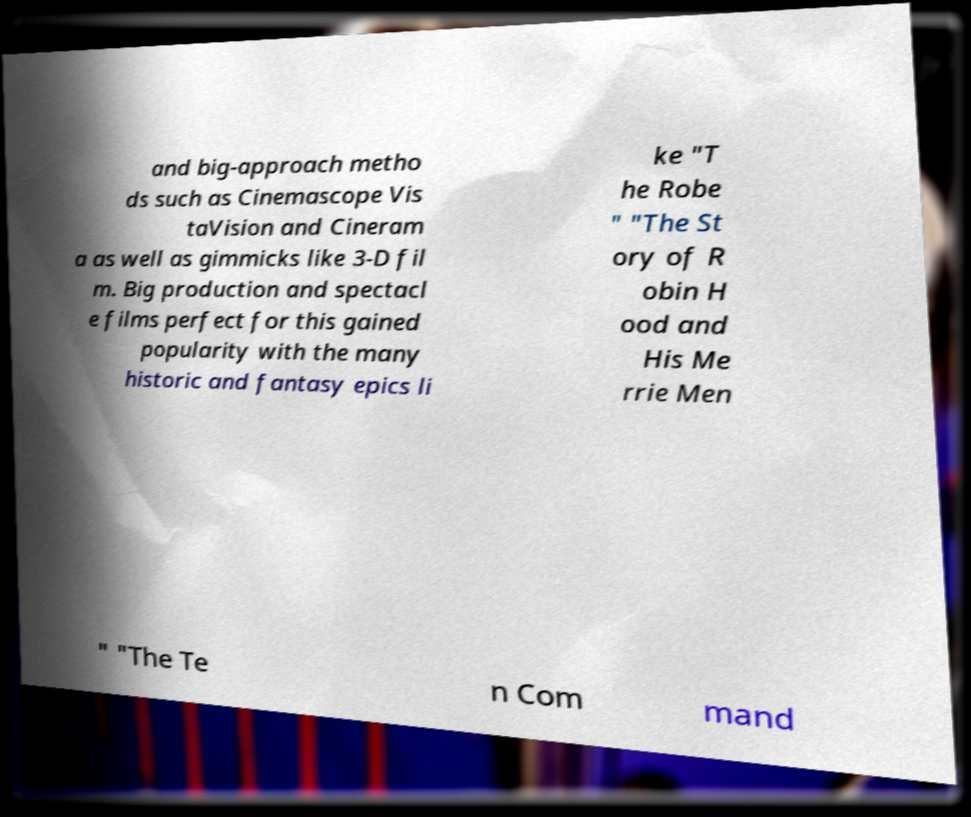Please identify and transcribe the text found in this image. and big-approach metho ds such as Cinemascope Vis taVision and Cineram a as well as gimmicks like 3-D fil m. Big production and spectacl e films perfect for this gained popularity with the many historic and fantasy epics li ke "T he Robe " "The St ory of R obin H ood and His Me rrie Men " "The Te n Com mand 